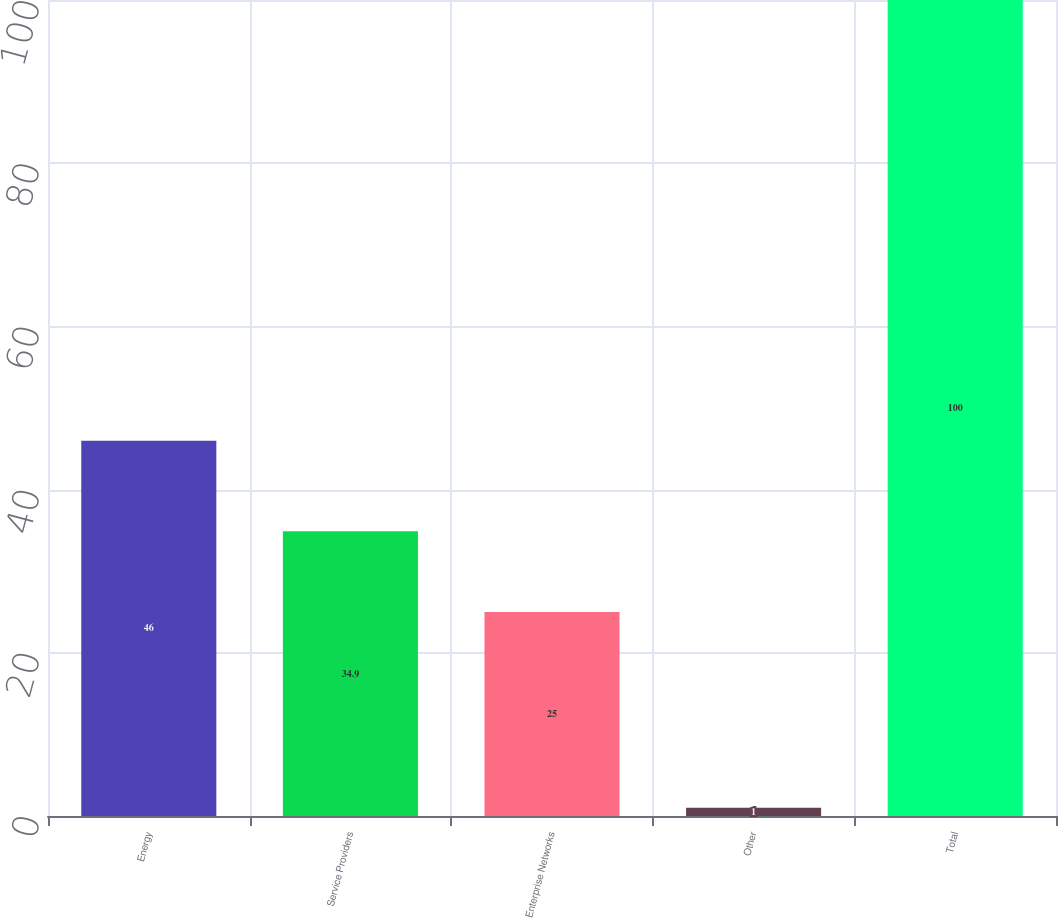<chart> <loc_0><loc_0><loc_500><loc_500><bar_chart><fcel>Energy<fcel>Service Providers<fcel>Enterprise Networks<fcel>Other<fcel>Total<nl><fcel>46<fcel>34.9<fcel>25<fcel>1<fcel>100<nl></chart> 